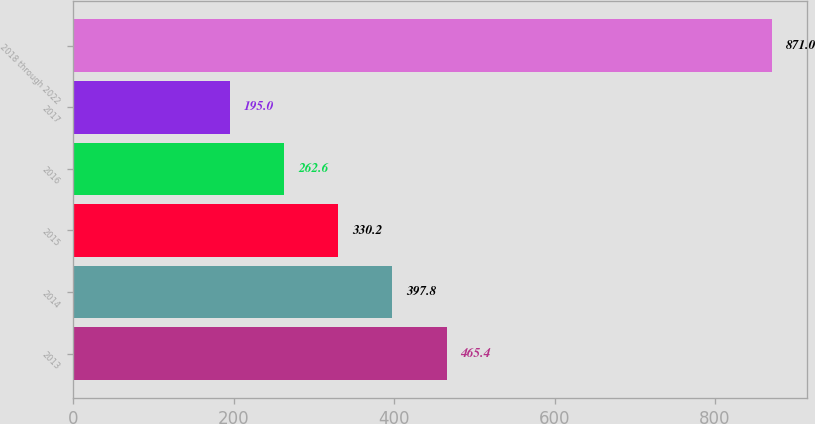Convert chart to OTSL. <chart><loc_0><loc_0><loc_500><loc_500><bar_chart><fcel>2013<fcel>2014<fcel>2015<fcel>2016<fcel>2017<fcel>2018 through 2022<nl><fcel>465.4<fcel>397.8<fcel>330.2<fcel>262.6<fcel>195<fcel>871<nl></chart> 